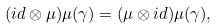<formula> <loc_0><loc_0><loc_500><loc_500>( i d \otimes \mu ) \mu ( \gamma ) = ( \mu \otimes i d ) \mu ( \gamma ) ,</formula> 